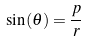<formula> <loc_0><loc_0><loc_500><loc_500>\sin ( \theta ) = \frac { p } { r }</formula> 